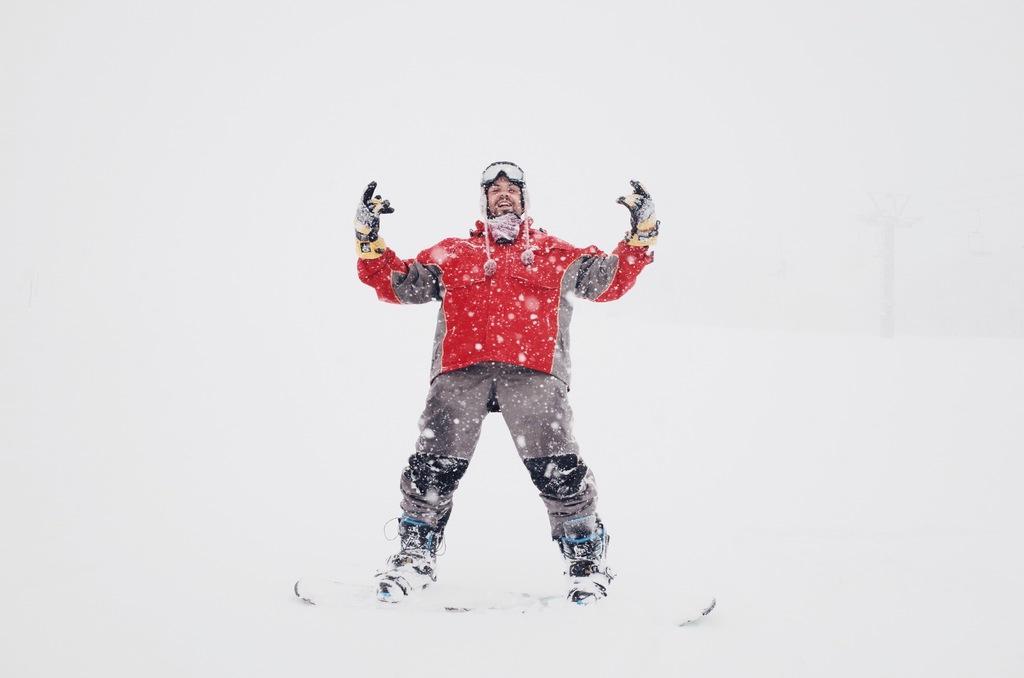Can you describe this image briefly? As we can see in the image there is snow and a person wearing red color jacket. 